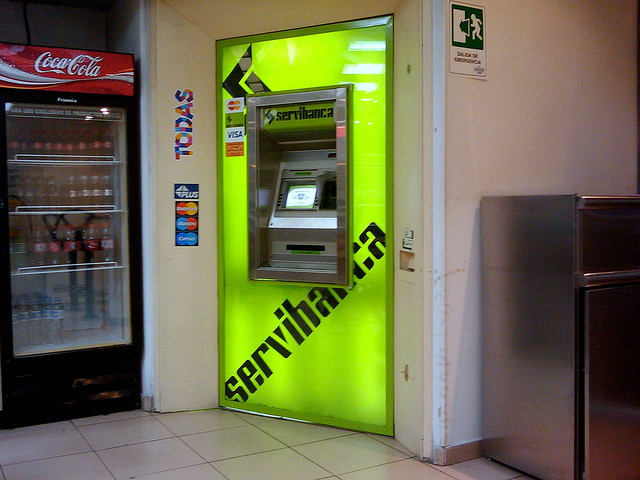<image>What language is on the ATM? The language on the ATM is unclear. It could be Spanish or Russian. What language is on the ATM? I am not sure what language is on the ATM. It can be both Spanish or Russian. 